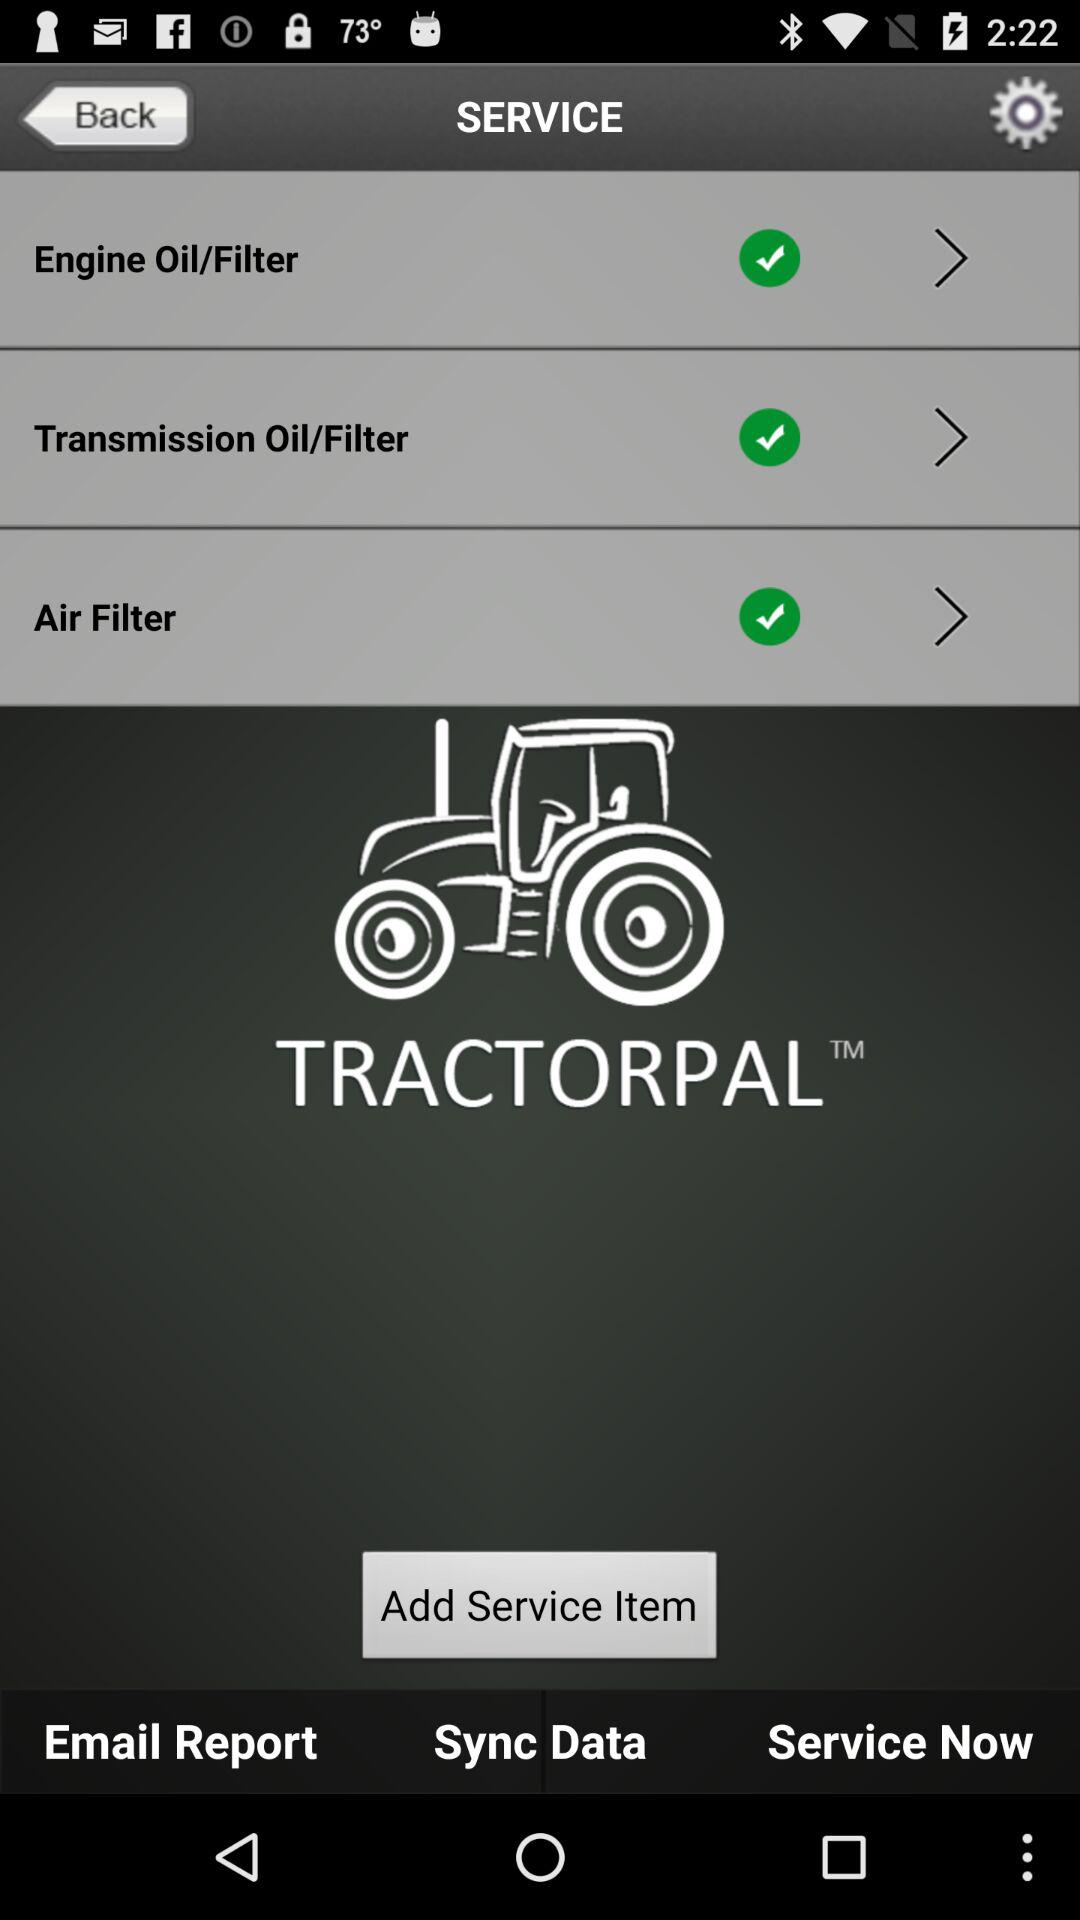What is the name of the application? The name of the application is "TRACTORPAL". 